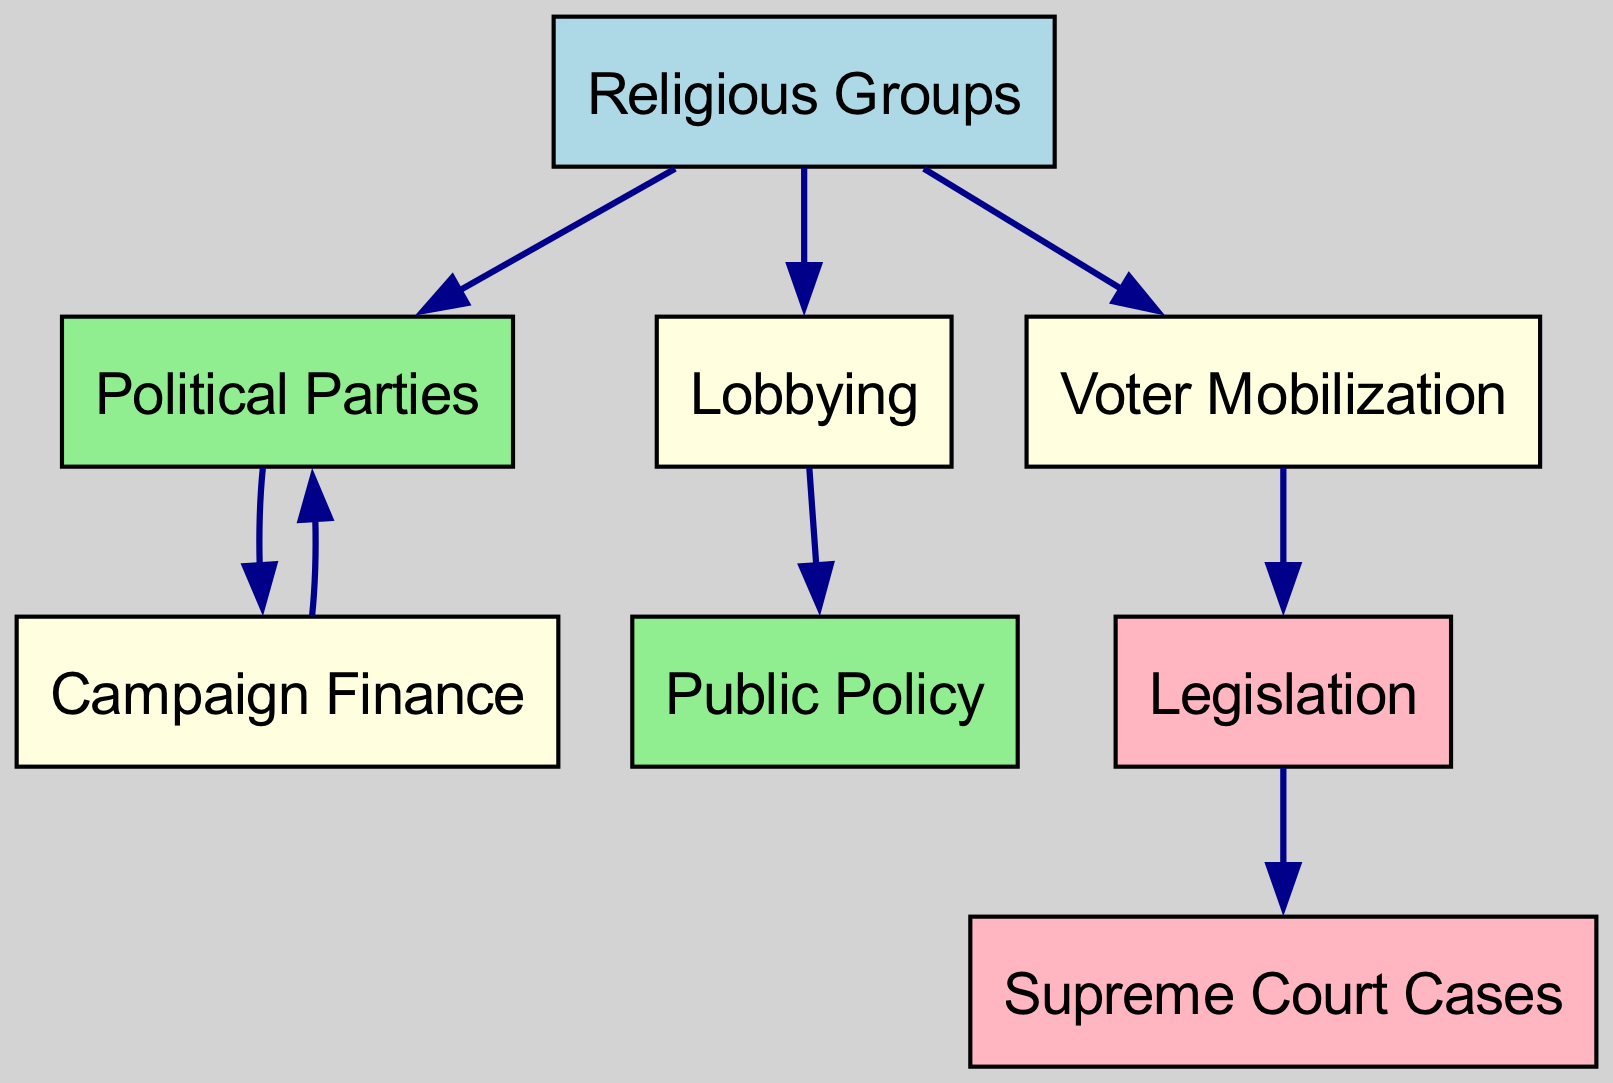What is the total number of nodes in the diagram? The diagram has eight nodes listed: Religious Groups, Political Parties, Public Policy, Lobbying, Voter Mobilization, Campaign Finance, Legislation, and Supreme Court Cases. Counting these nodes gives a total of eight.
Answer: 8 Which node is directly influenced by Lobbying? From the edges, it can be seen that Lobbying has a directed edge to Public Policy, indicating that Lobbying directly influences Public Policy.
Answer: Public Policy How many edges are in the diagram? The edges listed are from Religious Groups to Political Parties, Lobbying, and Voter Mobilization; from Political Parties to Campaign Finance; from Lobbying to Public Policy; from Voter Mobilization to Legislation; from Campaign Finance back to Political Parties; and from Legislation to Supreme Court Cases. Counting these gives a total of seven edges.
Answer: 7 Which node acts as an intermediary between Voter Mobilization and Legislation? Voter Mobilization has a direct edge to Legislation, but it does not have an intermediary node in this case. Instead, Voter Mobilization directly influences Legislation.
Answer: None What influences Campaign Finance according to the diagram? The diagram shows that Campaign Finance is influenced by Political Parties (as an edge goes from Political Parties to Campaign Finance) and is also involved in the cycle where it influences Political Parties back.
Answer: Political Parties What is the relationship between Legislation and Supreme Court Cases? The diagram indicates a directed edge from Legislation to Supreme Court Cases, meaning that Legislation influences Supreme Court Cases in some capacity.
Answer: Legislation influences Which type of relationship connects Political Parties and Campaign Finance? The connection between Political Parties and Campaign Finance is a directed one, where Political Parties influence Campaign Finance, as shown by the directed edge between these two nodes.
Answer: Directed influence What role do Religious Groups play in Voter Mobilization? The diagram illustrates that Religious Groups have a directed edge to Voter Mobilization, indicating that Religious Groups directly influence Voter Mobilization efforts.
Answer: Direct influence How does Public Policy correlate with Lobbying? The directed edge from Lobbying to Public Policy shows that Lobbying has a direct effect on Public Policy, establishing a clear relationship where Lobbying seeks to influence or shape Public Policy decisions.
Answer: Lobbying influences 